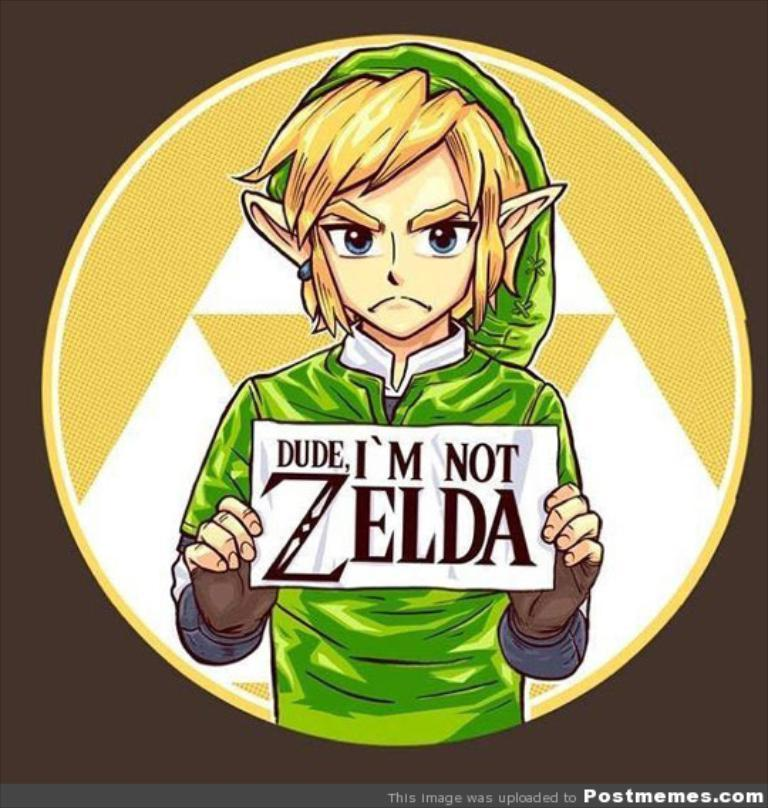<image>
Summarize the visual content of the image. angry elf in green holding sign that states "dude, i'm not zelda" 